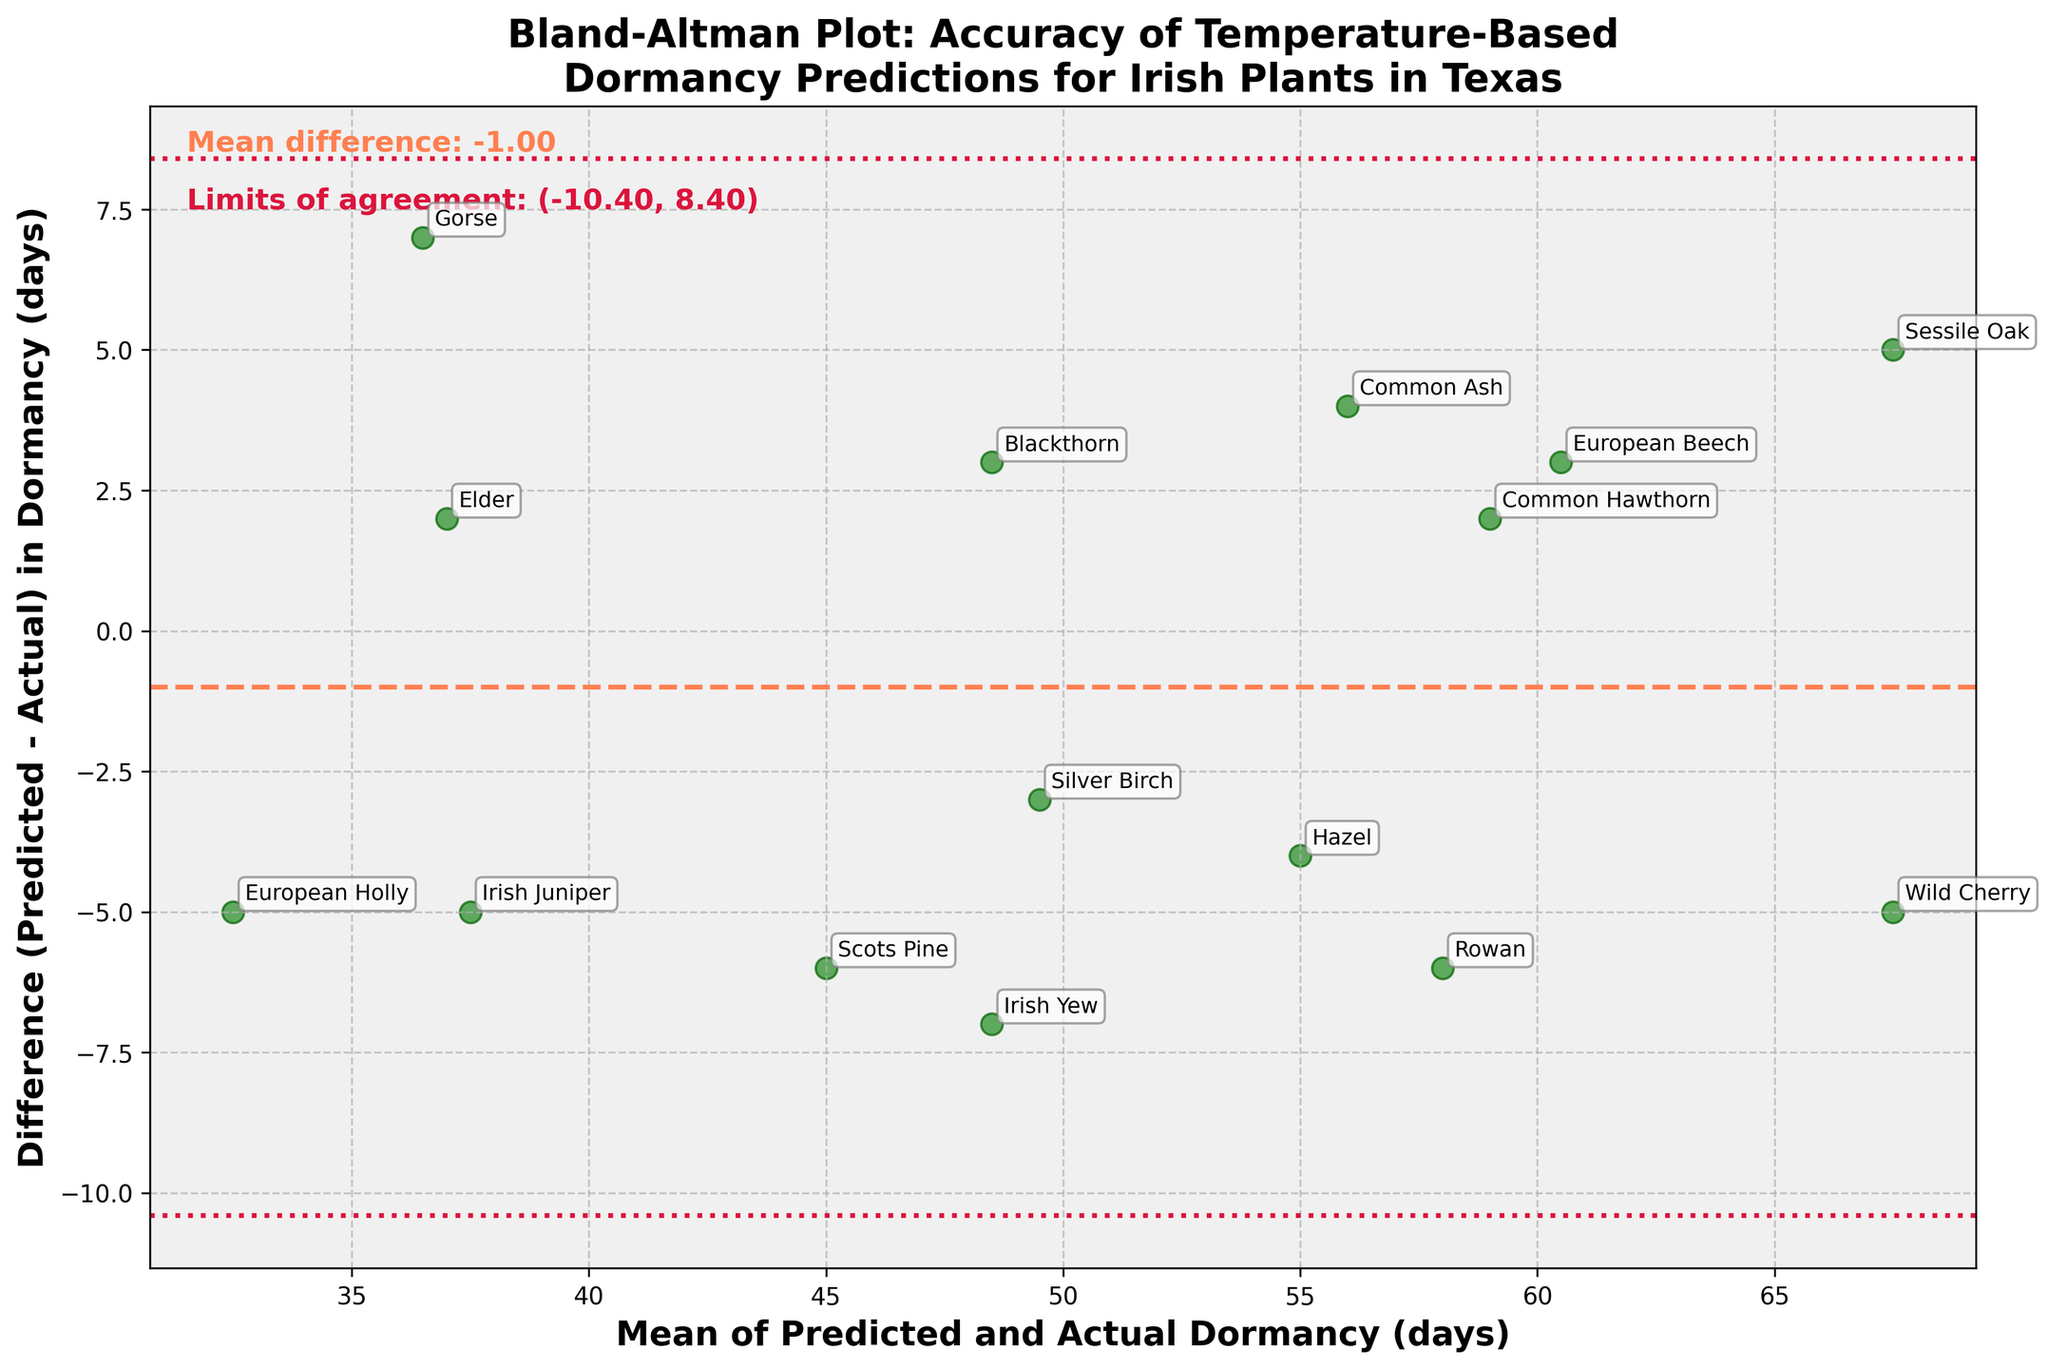What is the title of the Bland–Altman Plot? The plot's title is prominently displayed at the top, indicating the specific focus of the plot. It reads: "Bland-Altman Plot: Accuracy of Temperature-Based Dormancy Predictions for Irish Plants in Texas."
Answer: Bland-Altman Plot: Accuracy of Temperature-Based Dormancy Predictions for Irish Plants in Texas How many plant species are represented in the plot? By counting the data points or annotations labeled with plant species names, we can determine how many species are represented.
Answer: 15 What is the mean difference between predicted and actual dormancy? The mean difference is explicitly labeled on the plot with text in the top left area, showing the average discrepancy between predicted and actual dormancy days.
Answer: Mean difference: -1.33 What do the dashed lines on the plot represent? The dashed lines are aligned horizontally and indicate the mean difference and limits of agreement. The mean difference line is labeled "Mean difference," and the other two dashed lines above and below it represent the limits of agreement.
Answer: They represent the mean difference and limits of agreement What plant species has the largest negative difference between predicted and actual dormancy? To find the species with the largest negative difference, look for the point farthest below the zero line on the y-axis, which represents the difference. The annotation next to that point will indicate the species.
Answer: Gorse Which plant species have a positive difference between predicted and actual dormancy? Positive differences are indicated by points above the zero line on the y-axis. By locating these points and their respective annotations, we can identify the plant species.
Answer: Common Ash, European Beech, Hazel, Common Hawthorn, Gorse, Rowan, Scots Pine What are the limits of agreement for the differences in dormancy predictions? The limits of agreement values are specified in the text next to the plot, which states: "Limits of agreement: (lower limit, upper limit)."
Answer: Limits of agreement: (-10.94, 8.27) Which plant species has the actual dormancy closest to the mean dormancy of predicted and actual values? By analyzing the points closest to the central horizontal line of mean difference (around -1.33), we can find the species whose actual dormancy is closest to the mean dormancy value.
Answer: Common Hawthorn What is the range of actual dormancy days displayed on the plot's x-axis? The x-axis features the mean dormancy of predicted and actual values. By noting the minimum and maximum values on this axis, we can determine the range.
Answer: The range is from approximately 34 to 67 days Which two plant species have points relatively close to each other on the plot in terms of mean dormancy and difference? By visually inspecting the plot for clusters or neighboring points and reading their annotations, we can find species with similar mean dormancy and difference values.
Answer: Silver Birch and Elder 